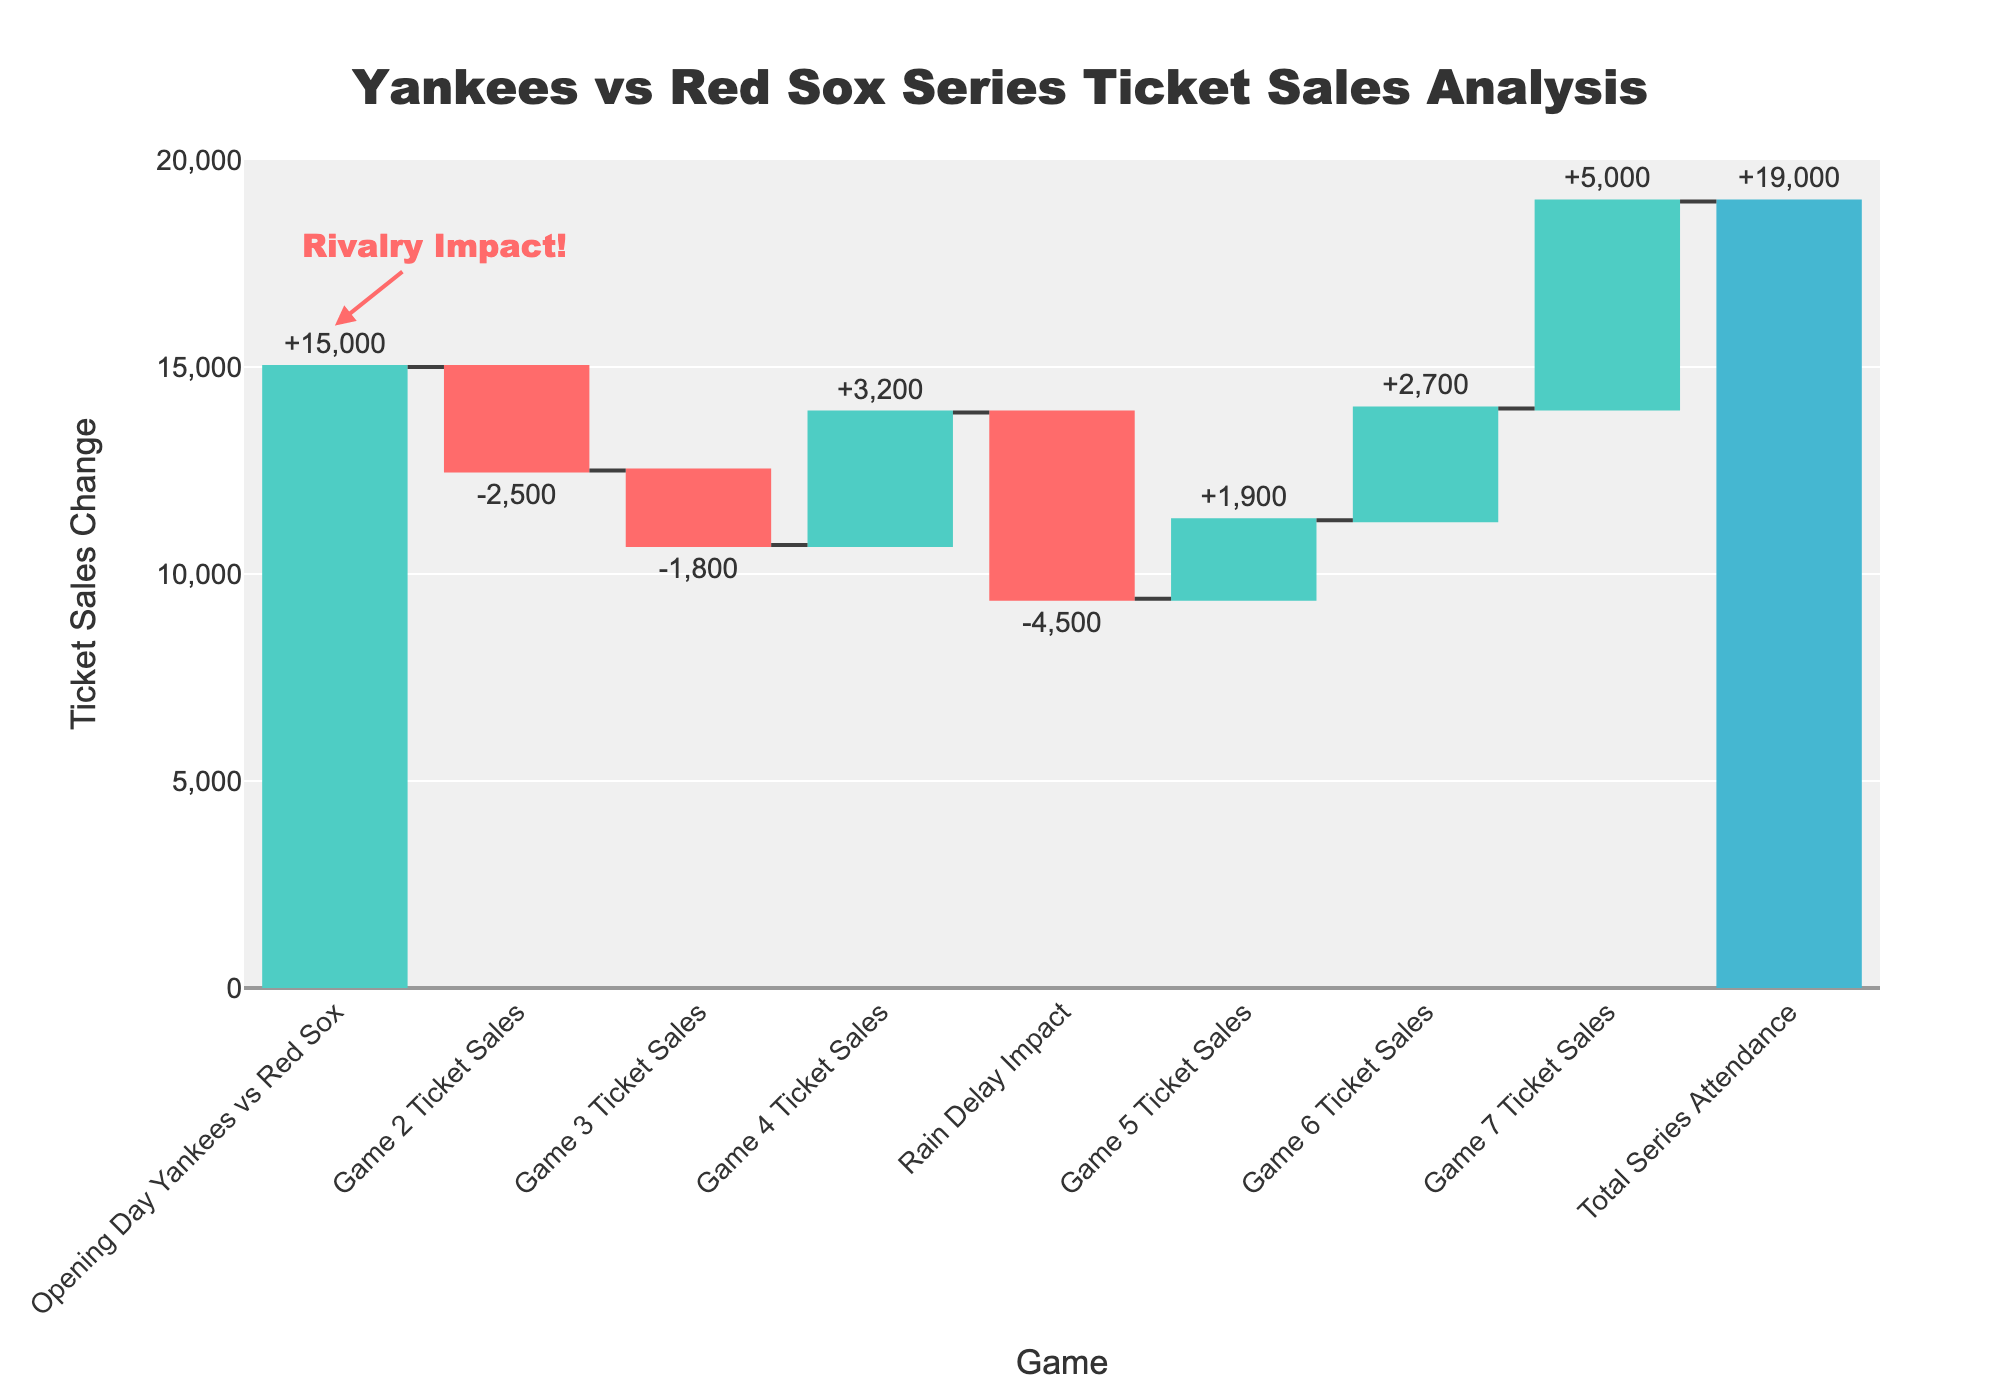What is the title of the chart? The chart title is displayed at the top in the center. It reads "Yankees vs Red Sox Series Ticket Sales Analysis".
Answer: Yankees vs Red Sox Series Ticket Sales Analysis How many games are represented in the data? Each bar in the chart represents a game or the Rain Delay Impact, indicated by the labels at the bottom of each bar. Counting each individually will give the total.
Answer: 7 games What is the total series attendance? The last bar, which is colored differently (blue), represents the total series attendance. The value marked outside this bar shows the total.
Answer: 19,000 Which game had the highest increase in ticket sales? Identify the bar with the highest positive value, i.e., the tallest green bar. The label beneath it indicates which game it corresponds to.
Answer: Game 7 What was the impact of the Rain Delay on ticket sales? Locate the bar labeled "Rain Delay Impact" and observe the change indicated outside this bar. The number indicates how much the sales decreased.
Answer: -4,500 What is the ticket sales change for Game 4? Locate the bar corresponding to Game 4 and observe the change indicated outside this bar. The number tells us how much the ticket sales changed.
Answer: +3,200 How many total decreases in ticket sales occurred over the series? Count the number of red bars, as they indicate decreases in ticket sales. Each red bar represents a moment of decline.
Answer: 3 What is the overall change in ticket sales from Game 1 to Game 3? To find the change from Game 1 to Game 3, sum the values of the tallies (positive and negative) for the first three games. That is 15,000 - 2,500 - 1,800.
Answer: 10,700 Compare the change in ticket sales between Game 5 and Game 6. Which game had a higher increase? Look at the values outside the bars for Game 5 and Game 6. Compare the two values. Game 6's value is larger than Game 5's.
Answer: Game 6 